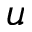Convert formula to latex. <formula><loc_0><loc_0><loc_500><loc_500>u</formula> 